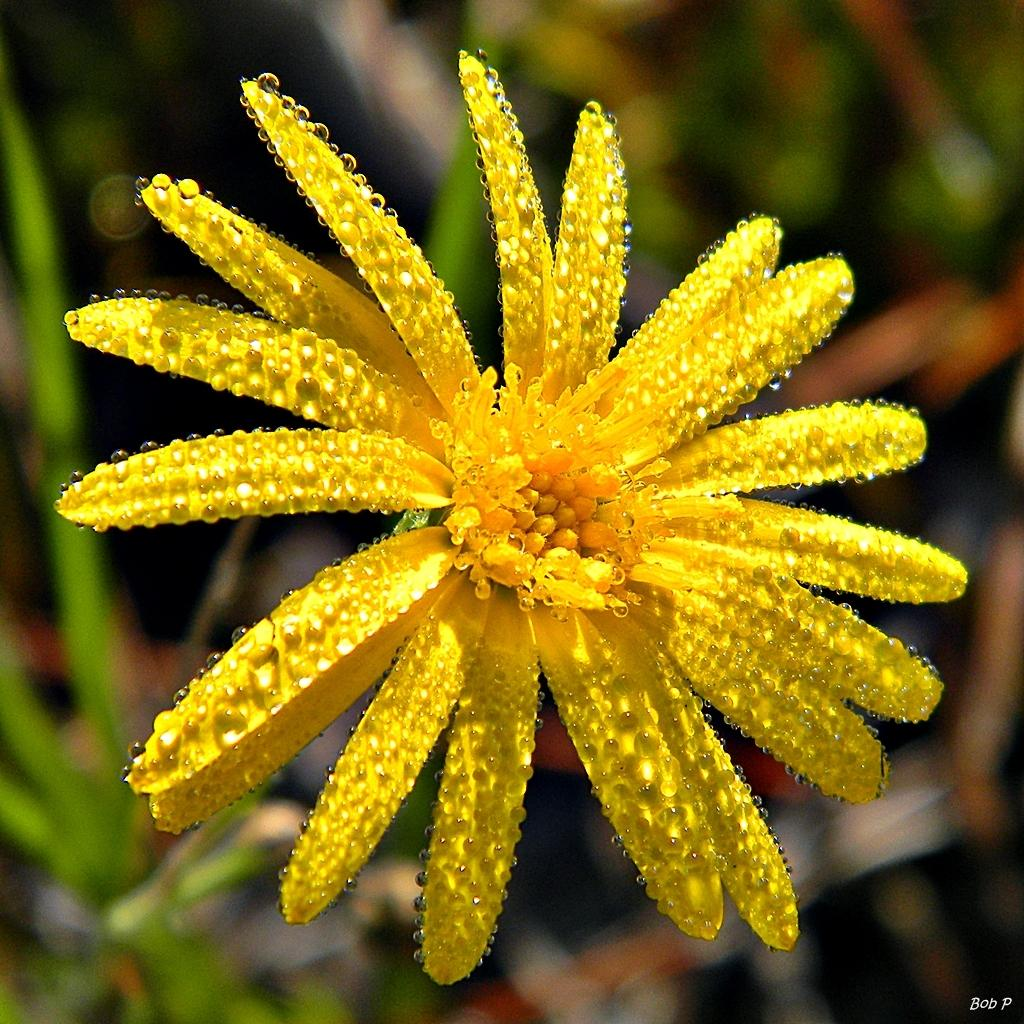What is the main subject of the image? There is a flower in the image. Can you describe the background of the image? The background of the image is blurry. Where is the text located in the image? The text is in the bottom right corner of the image. What type of cast can be seen supporting the flower in the image? There is no cast present in the image; it features a flower with a blurry background and text in the bottom right corner. Can you provide an example of a rule that applies to the flower in the image? There is no rule mentioned or implied in the image, as it only contains a flower, a blurry background, and text in the bottom right corner. 